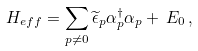Convert formula to latex. <formula><loc_0><loc_0><loc_500><loc_500>H _ { e f f } = \sum _ { p \neq 0 } \widetilde { \epsilon } _ { p } \alpha _ { p } ^ { \dagger } \alpha _ { p } + \, E _ { 0 } \, ,</formula> 